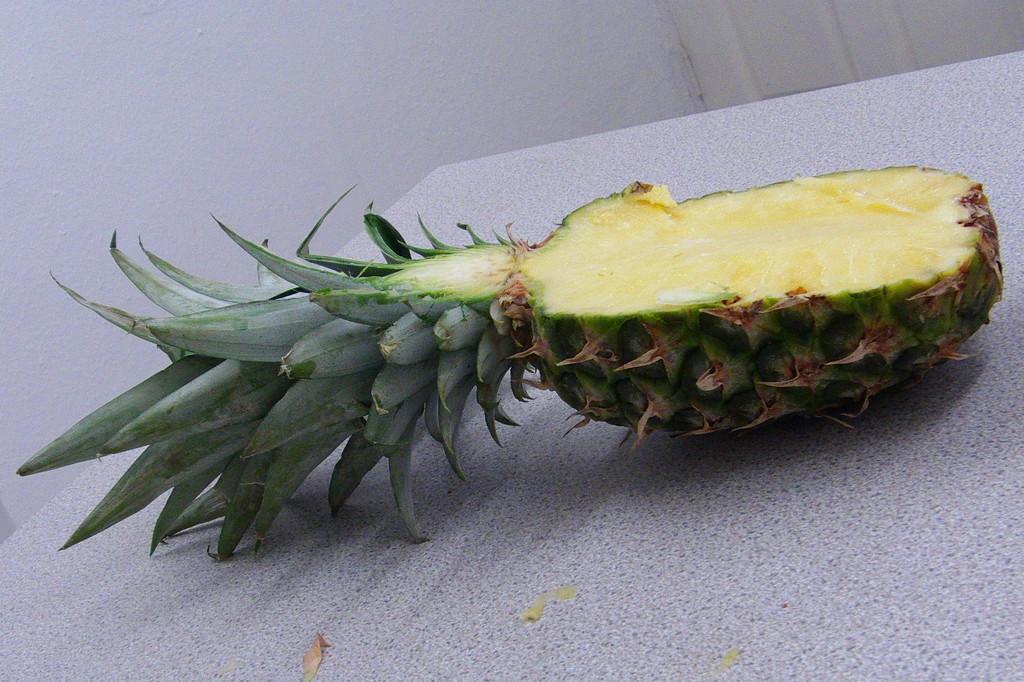In one or two sentences, can you explain what this image depicts? In this image we can see a pineapple on the table, also we can see the wall. 